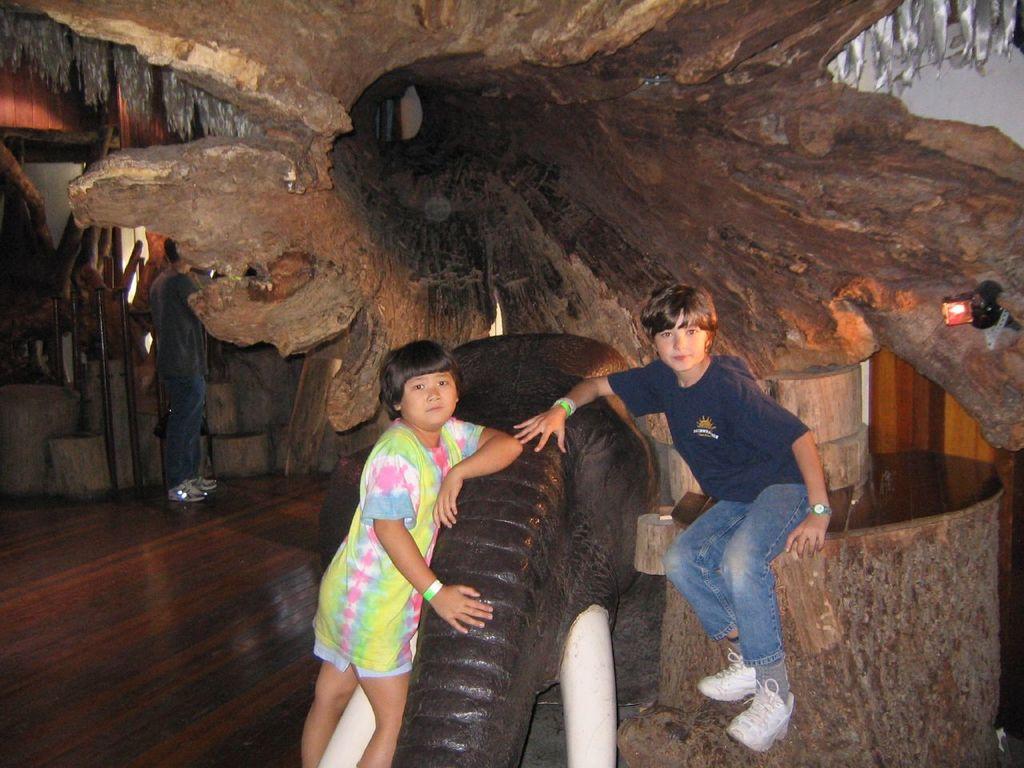Describe this image in one or two sentences. In this picture i could see two kids standing on beside the elephant and the other sitting on the wooden plank. In the background i could see a big wooden plank. 